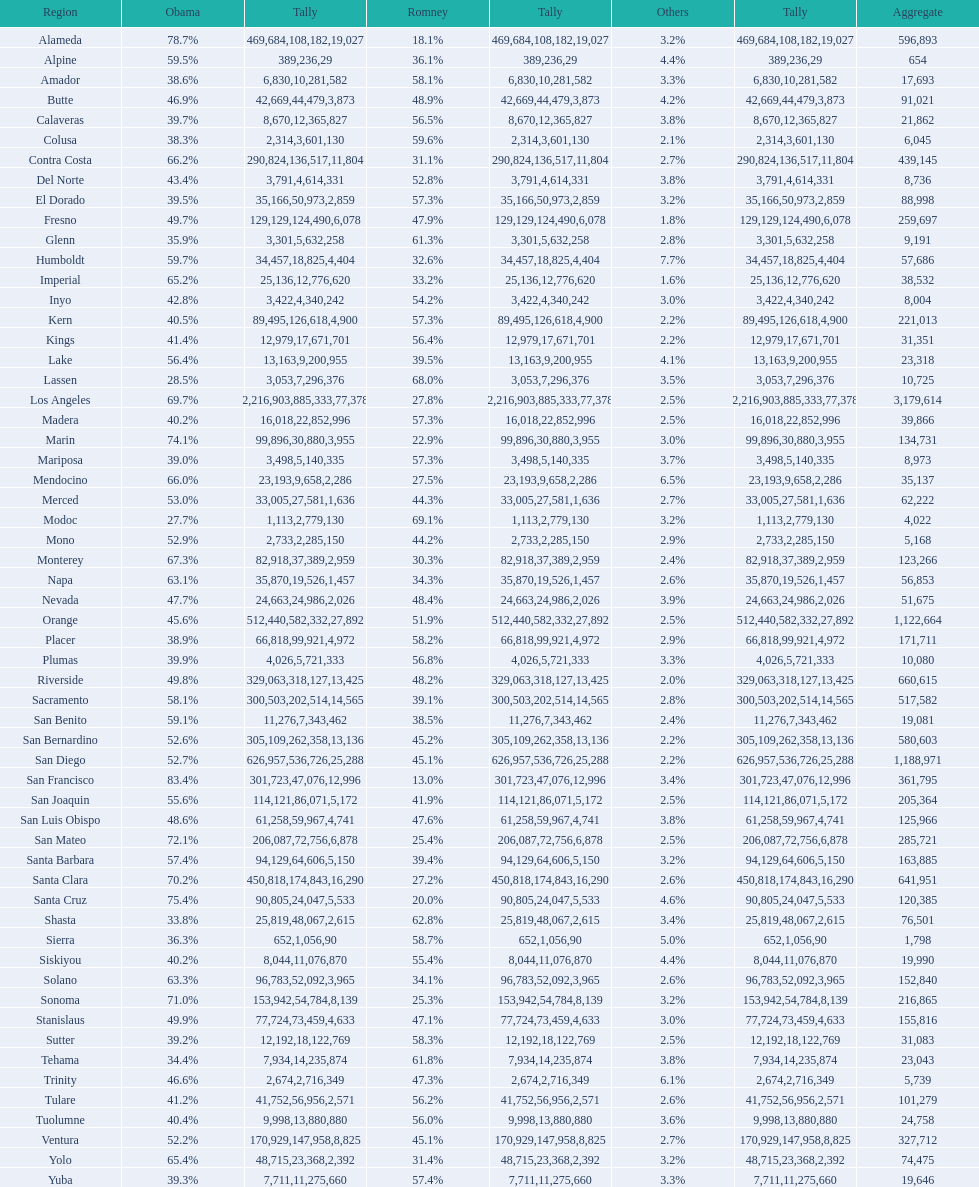Which county had the lower percentage votes for obama: amador, humboldt, or lake? Amador. 